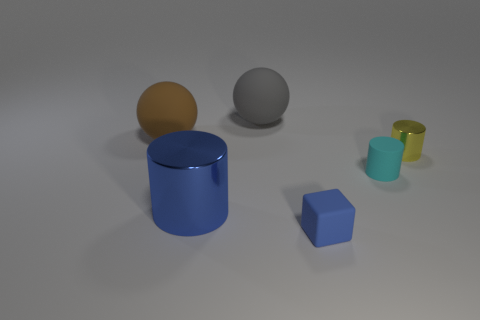Add 2 large rubber cylinders. How many objects exist? 8 Subtract all cubes. How many objects are left? 5 Subtract 0 blue balls. How many objects are left? 6 Subtract all tiny blue things. Subtract all matte blocks. How many objects are left? 4 Add 5 big balls. How many big balls are left? 7 Add 4 big metallic blocks. How many big metallic blocks exist? 4 